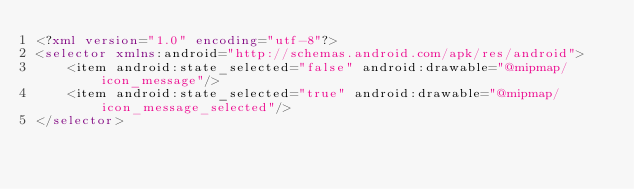Convert code to text. <code><loc_0><loc_0><loc_500><loc_500><_XML_><?xml version="1.0" encoding="utf-8"?>
<selector xmlns:android="http://schemas.android.com/apk/res/android">
    <item android:state_selected="false" android:drawable="@mipmap/icon_message"/>
    <item android:state_selected="true" android:drawable="@mipmap/icon_message_selected"/>
</selector></code> 